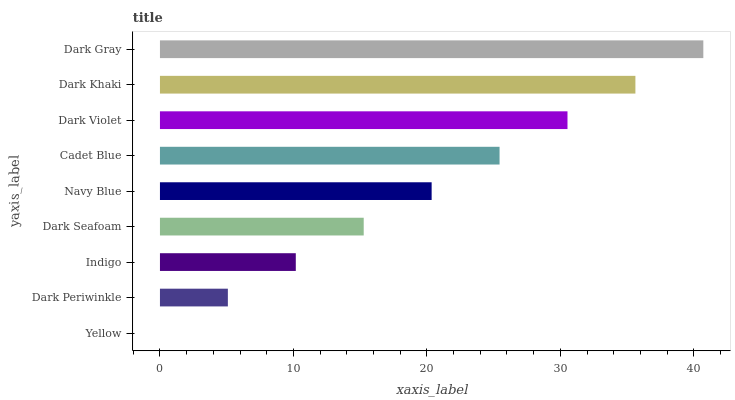Is Yellow the minimum?
Answer yes or no. Yes. Is Dark Gray the maximum?
Answer yes or no. Yes. Is Dark Periwinkle the minimum?
Answer yes or no. No. Is Dark Periwinkle the maximum?
Answer yes or no. No. Is Dark Periwinkle greater than Yellow?
Answer yes or no. Yes. Is Yellow less than Dark Periwinkle?
Answer yes or no. Yes. Is Yellow greater than Dark Periwinkle?
Answer yes or no. No. Is Dark Periwinkle less than Yellow?
Answer yes or no. No. Is Navy Blue the high median?
Answer yes or no. Yes. Is Navy Blue the low median?
Answer yes or no. Yes. Is Dark Violet the high median?
Answer yes or no. No. Is Dark Periwinkle the low median?
Answer yes or no. No. 